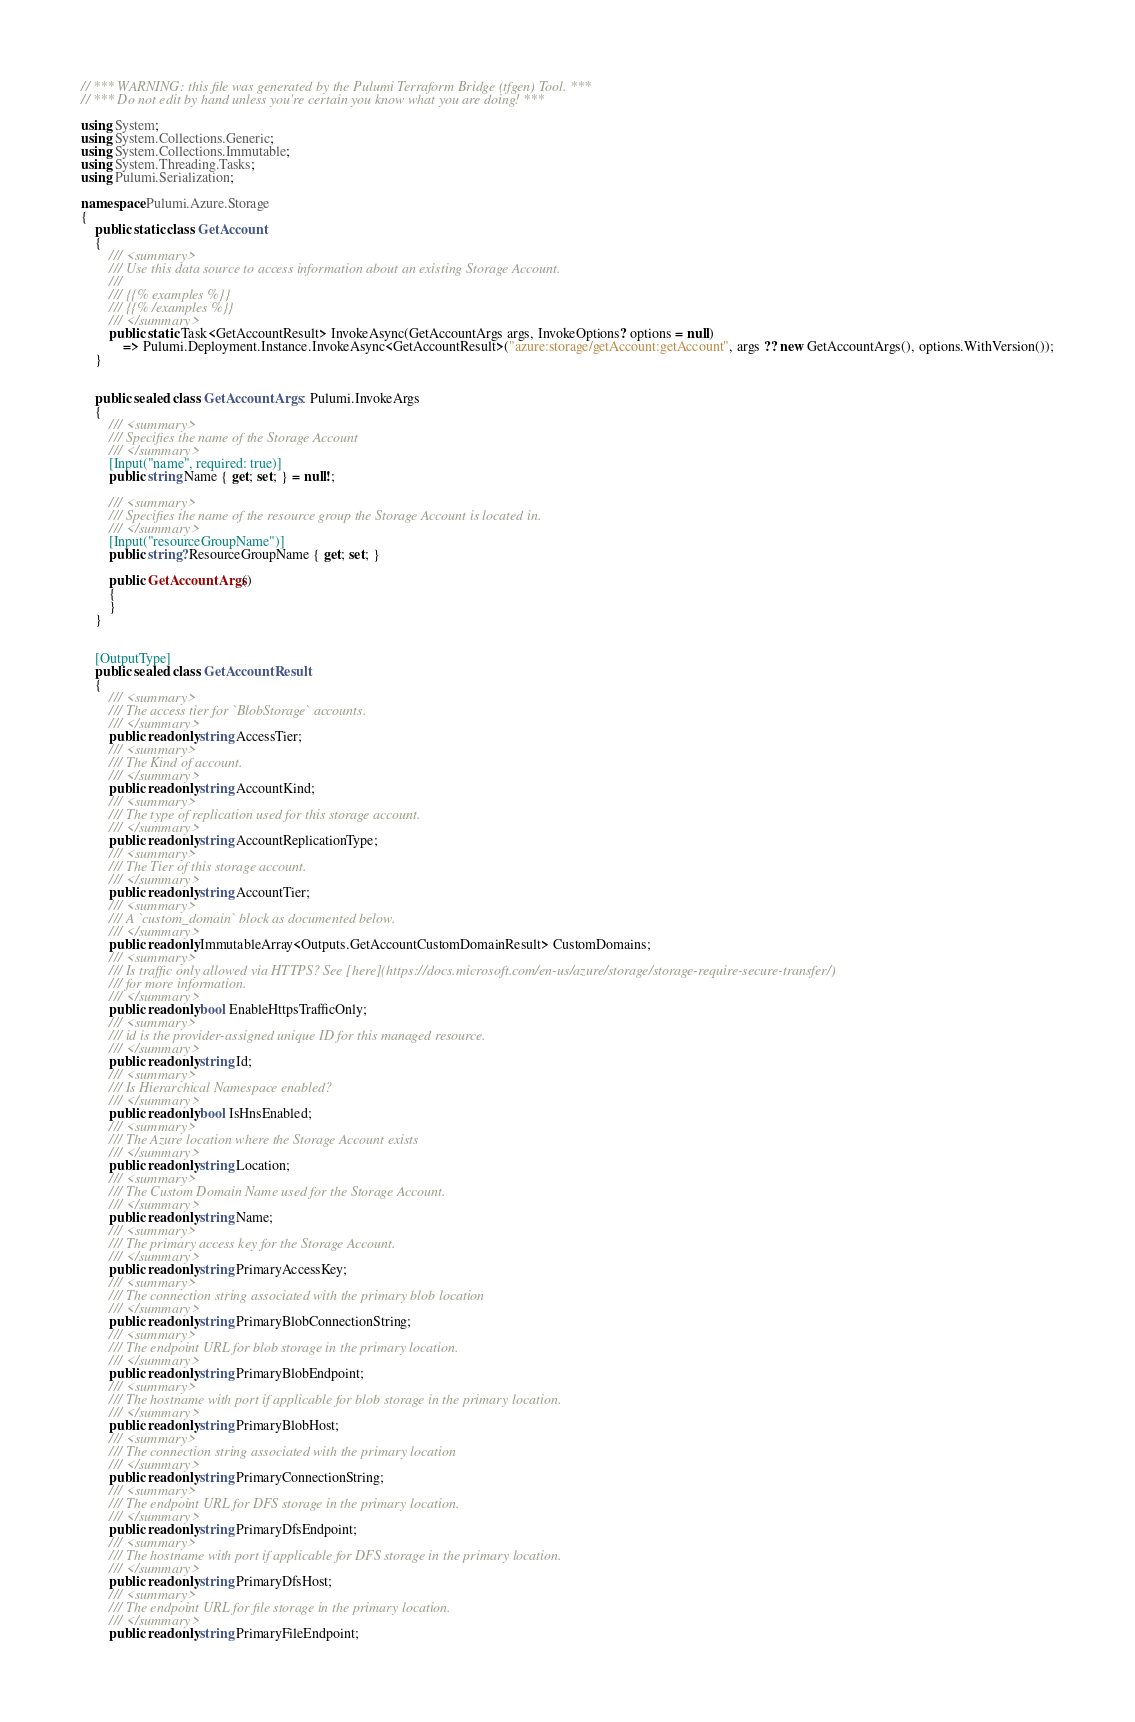<code> <loc_0><loc_0><loc_500><loc_500><_C#_>// *** WARNING: this file was generated by the Pulumi Terraform Bridge (tfgen) Tool. ***
// *** Do not edit by hand unless you're certain you know what you are doing! ***

using System;
using System.Collections.Generic;
using System.Collections.Immutable;
using System.Threading.Tasks;
using Pulumi.Serialization;

namespace Pulumi.Azure.Storage
{
    public static class GetAccount
    {
        /// <summary>
        /// Use this data source to access information about an existing Storage Account.
        /// 
        /// {{% examples %}}
        /// {{% /examples %}}
        /// </summary>
        public static Task<GetAccountResult> InvokeAsync(GetAccountArgs args, InvokeOptions? options = null)
            => Pulumi.Deployment.Instance.InvokeAsync<GetAccountResult>("azure:storage/getAccount:getAccount", args ?? new GetAccountArgs(), options.WithVersion());
    }


    public sealed class GetAccountArgs : Pulumi.InvokeArgs
    {
        /// <summary>
        /// Specifies the name of the Storage Account
        /// </summary>
        [Input("name", required: true)]
        public string Name { get; set; } = null!;

        /// <summary>
        /// Specifies the name of the resource group the Storage Account is located in.
        /// </summary>
        [Input("resourceGroupName")]
        public string? ResourceGroupName { get; set; }

        public GetAccountArgs()
        {
        }
    }


    [OutputType]
    public sealed class GetAccountResult
    {
        /// <summary>
        /// The access tier for `BlobStorage` accounts.
        /// </summary>
        public readonly string AccessTier;
        /// <summary>
        /// The Kind of account.
        /// </summary>
        public readonly string AccountKind;
        /// <summary>
        /// The type of replication used for this storage account.
        /// </summary>
        public readonly string AccountReplicationType;
        /// <summary>
        /// The Tier of this storage account.
        /// </summary>
        public readonly string AccountTier;
        /// <summary>
        /// A `custom_domain` block as documented below.
        /// </summary>
        public readonly ImmutableArray<Outputs.GetAccountCustomDomainResult> CustomDomains;
        /// <summary>
        /// Is traffic only allowed via HTTPS? See [here](https://docs.microsoft.com/en-us/azure/storage/storage-require-secure-transfer/)
        /// for more information.
        /// </summary>
        public readonly bool EnableHttpsTrafficOnly;
        /// <summary>
        /// id is the provider-assigned unique ID for this managed resource.
        /// </summary>
        public readonly string Id;
        /// <summary>
        /// Is Hierarchical Namespace enabled?
        /// </summary>
        public readonly bool IsHnsEnabled;
        /// <summary>
        /// The Azure location where the Storage Account exists
        /// </summary>
        public readonly string Location;
        /// <summary>
        /// The Custom Domain Name used for the Storage Account.
        /// </summary>
        public readonly string Name;
        /// <summary>
        /// The primary access key for the Storage Account.
        /// </summary>
        public readonly string PrimaryAccessKey;
        /// <summary>
        /// The connection string associated with the primary blob location
        /// </summary>
        public readonly string PrimaryBlobConnectionString;
        /// <summary>
        /// The endpoint URL for blob storage in the primary location.
        /// </summary>
        public readonly string PrimaryBlobEndpoint;
        /// <summary>
        /// The hostname with port if applicable for blob storage in the primary location.
        /// </summary>
        public readonly string PrimaryBlobHost;
        /// <summary>
        /// The connection string associated with the primary location
        /// </summary>
        public readonly string PrimaryConnectionString;
        /// <summary>
        /// The endpoint URL for DFS storage in the primary location.
        /// </summary>
        public readonly string PrimaryDfsEndpoint;
        /// <summary>
        /// The hostname with port if applicable for DFS storage in the primary location.
        /// </summary>
        public readonly string PrimaryDfsHost;
        /// <summary>
        /// The endpoint URL for file storage in the primary location.
        /// </summary>
        public readonly string PrimaryFileEndpoint;</code> 